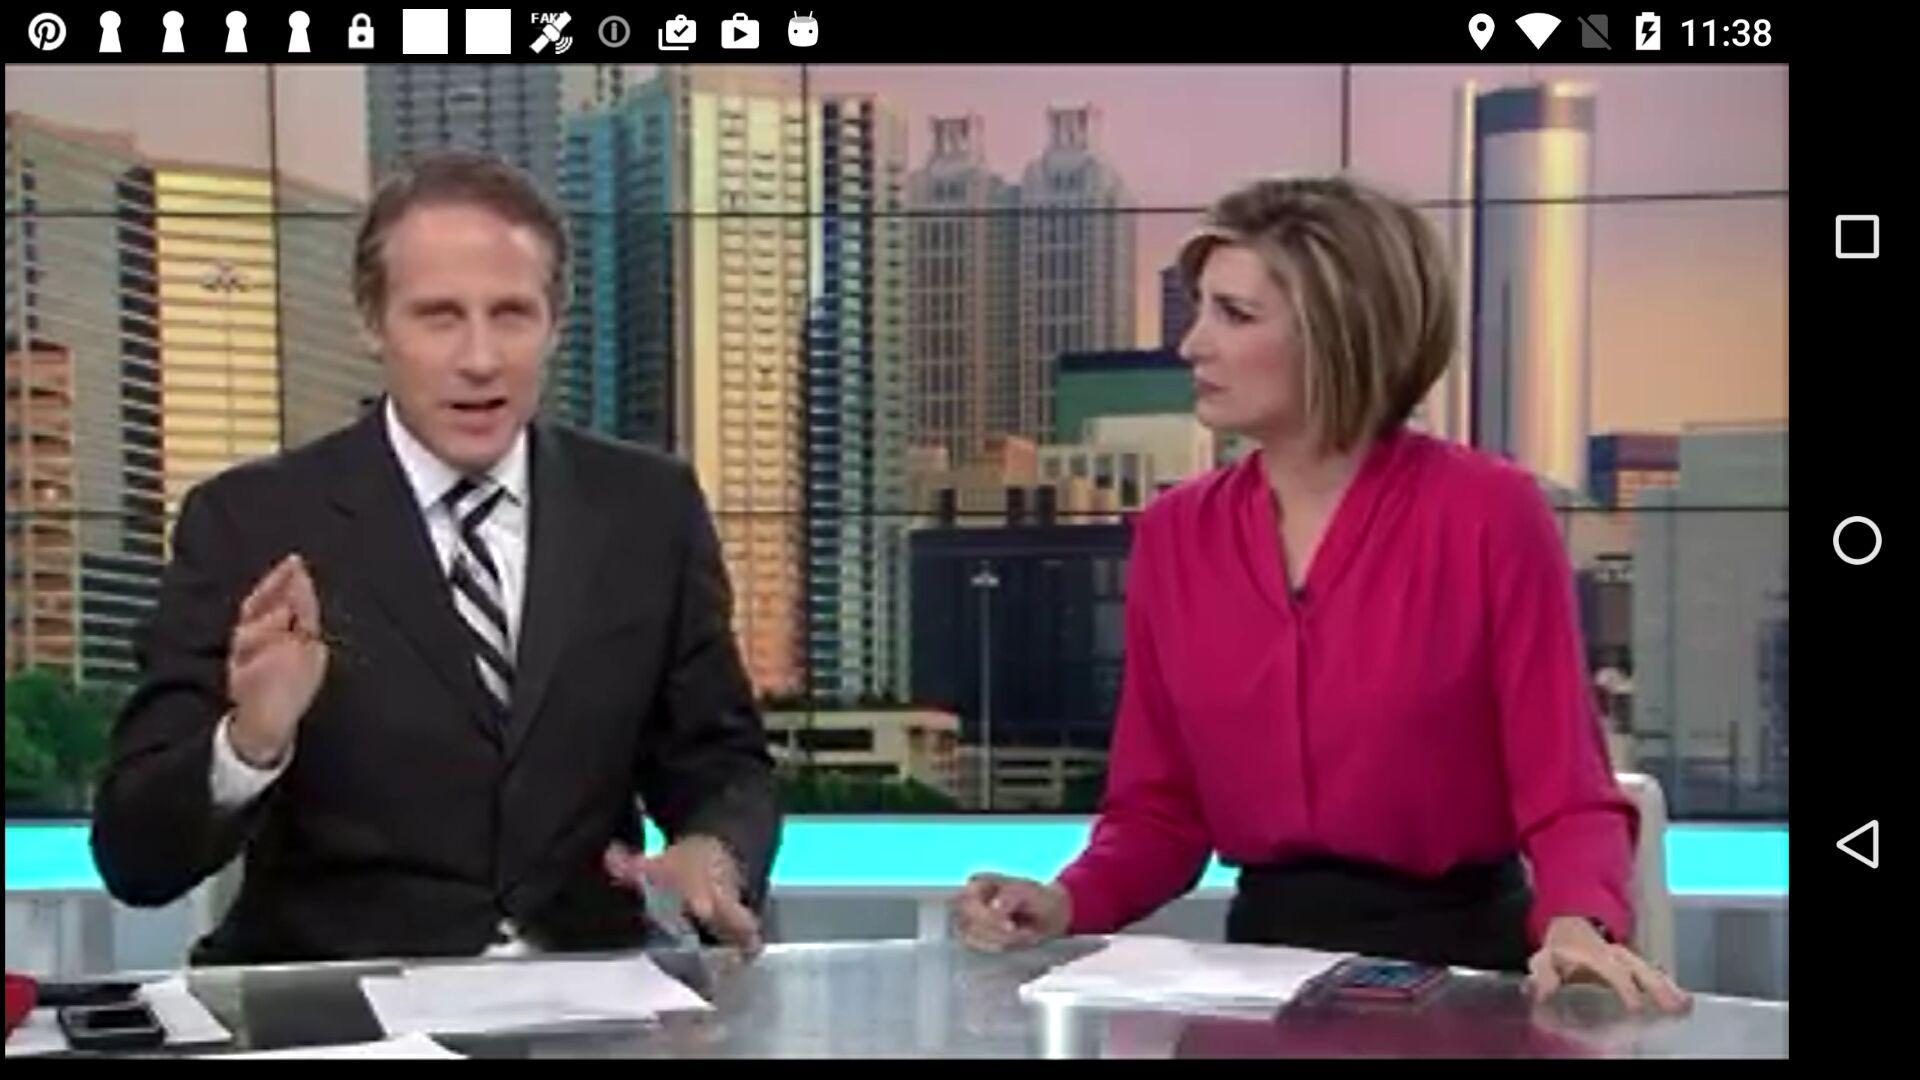What is the headline of the news? The headlines are "U.S. launches cruise missile strike on Syria after chemical weapons attack", "FULL TEXT | Pres. Trump's statement on Syria attack" and "EXCLUSIVE POLL | 47% of district 6 voters don't like Trump". 